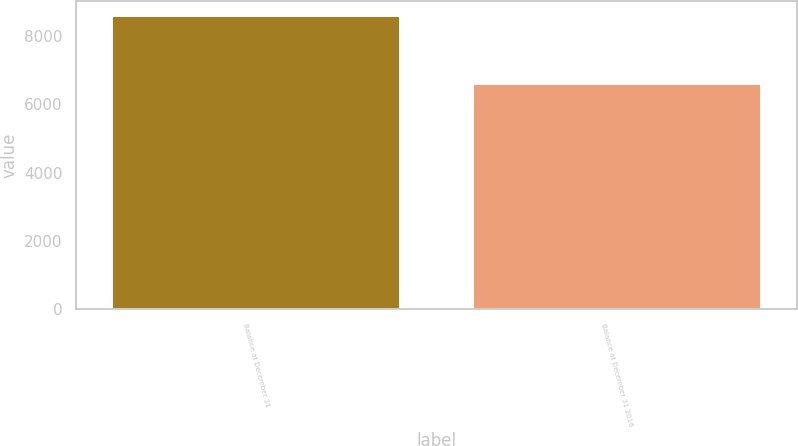Convert chart to OTSL. <chart><loc_0><loc_0><loc_500><loc_500><bar_chart><fcel>Balance at December 31<fcel>Balance at December 31 2016<nl><fcel>8589<fcel>6586<nl></chart> 